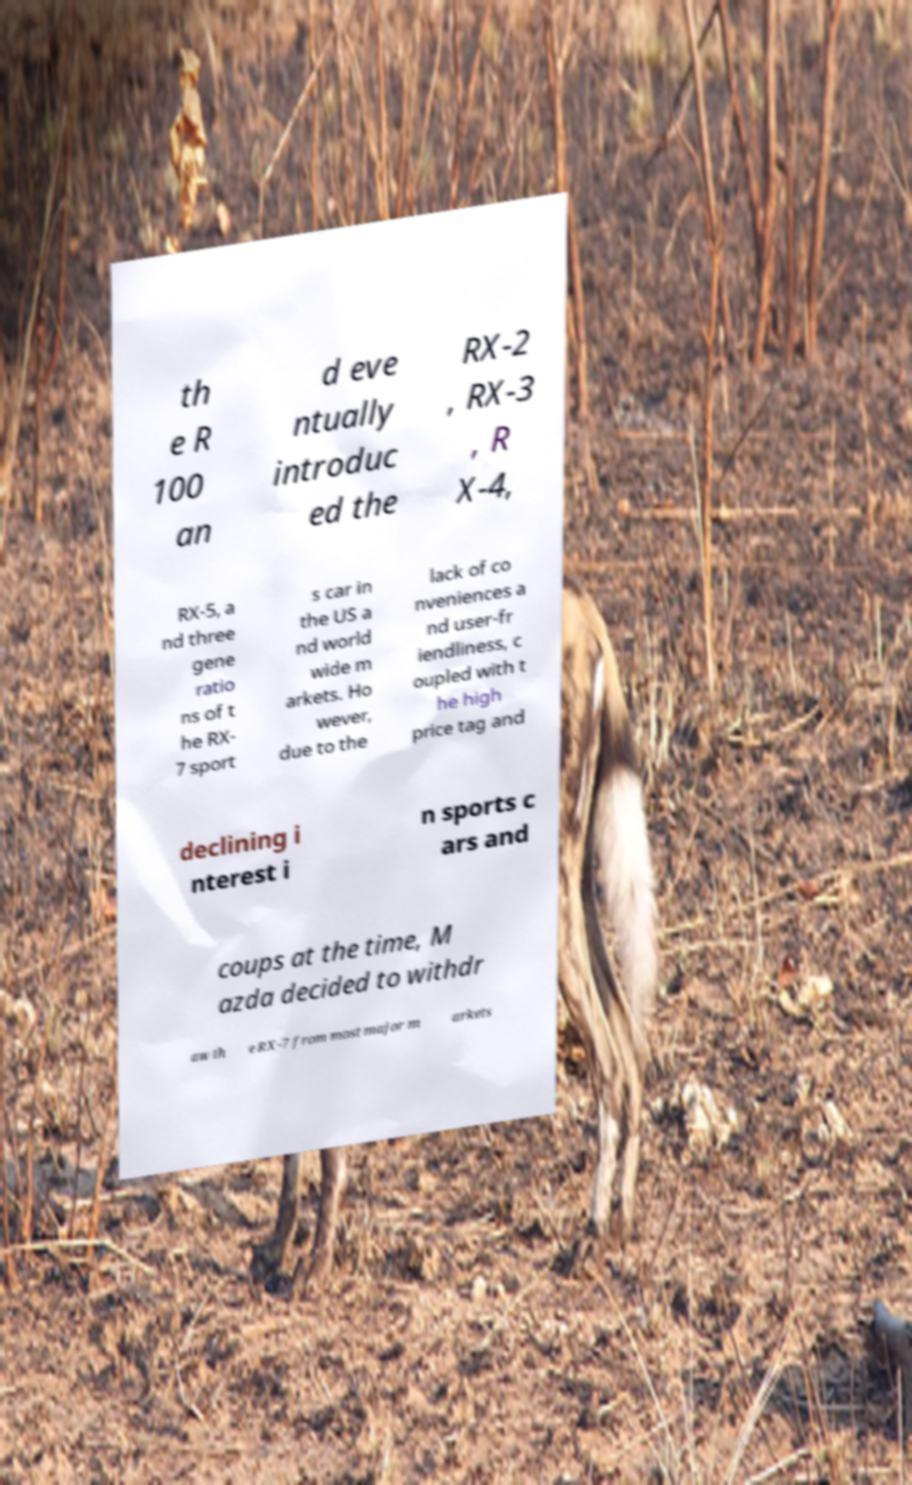Could you assist in decoding the text presented in this image and type it out clearly? th e R 100 an d eve ntually introduc ed the RX-2 , RX-3 , R X-4, RX-5, a nd three gene ratio ns of t he RX- 7 sport s car in the US a nd world wide m arkets. Ho wever, due to the lack of co nveniences a nd user-fr iendliness, c oupled with t he high price tag and declining i nterest i n sports c ars and coups at the time, M azda decided to withdr aw th e RX-7 from most major m arkets 